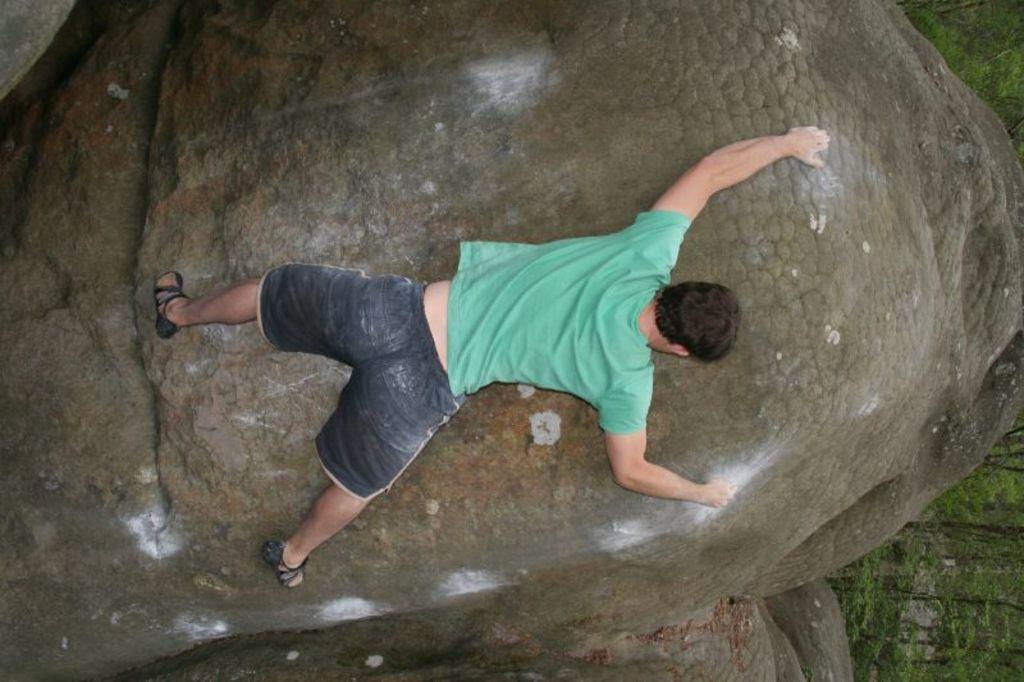Please provide a concise description of this image. In this image we can see many trees at the right side of the image. A person is climbing a rock in the image. 